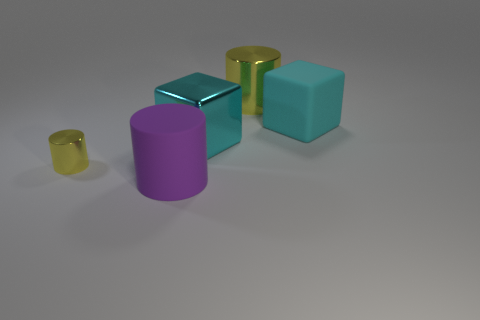There is a big cylinder behind the cyan metallic thing; does it have the same color as the big rubber object left of the large metallic cube? no 